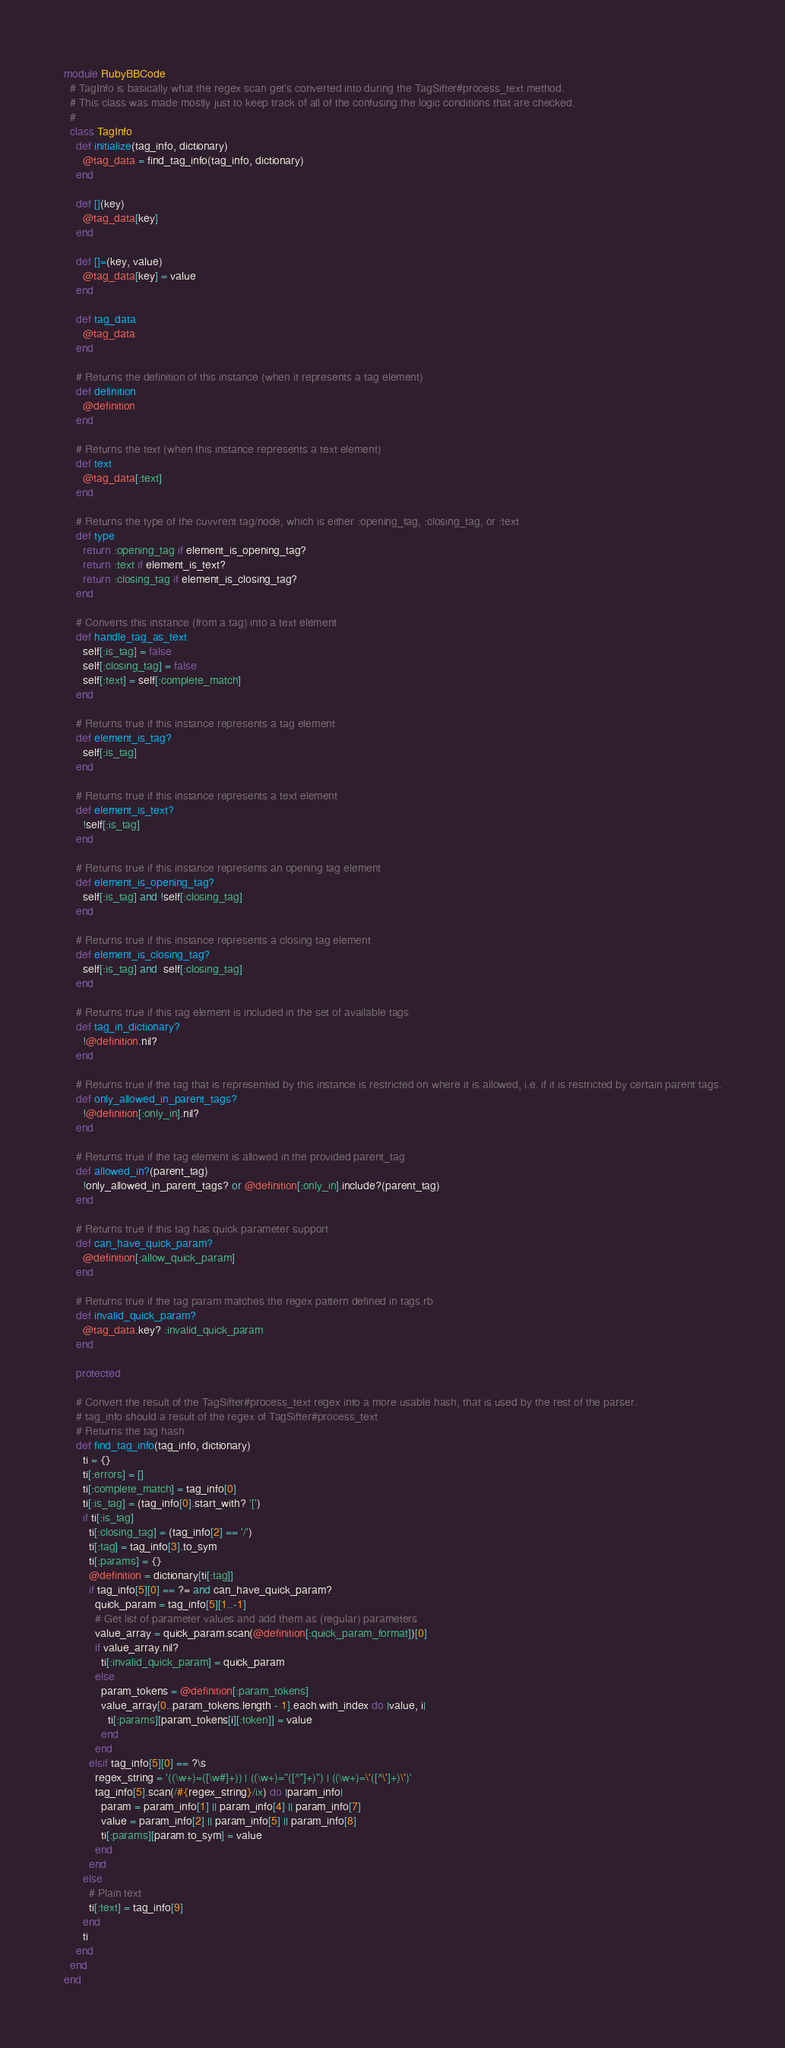<code> <loc_0><loc_0><loc_500><loc_500><_Ruby_>module RubyBBCode
  # TagInfo is basically what the regex scan get's converted into during the TagSifter#process_text method.
  # This class was made mostly just to keep track of all of the confusing the logic conditions that are checked.
  #
  class TagInfo
    def initialize(tag_info, dictionary)
      @tag_data = find_tag_info(tag_info, dictionary)
    end

    def [](key)
      @tag_data[key]
    end

    def []=(key, value)
      @tag_data[key] = value
    end

    def tag_data
      @tag_data
    end

    # Returns the definition of this instance (when it represents a tag element)
    def definition
      @definition
    end

    # Returns the text (when this instance represents a text element)
    def text
      @tag_data[:text]
    end

    # Returns the type of the cuvvrent tag/node, which is either :opening_tag, :closing_tag, or :text
    def type
      return :opening_tag if element_is_opening_tag?
      return :text if element_is_text?
      return :closing_tag if element_is_closing_tag?
    end

    # Converts this instance (from a tag) into a text element
    def handle_tag_as_text
      self[:is_tag] = false
      self[:closing_tag] = false
      self[:text] = self[:complete_match]
    end

    # Returns true if this instance represents a tag element
    def element_is_tag?
      self[:is_tag]
    end

    # Returns true if this instance represents a text element
    def element_is_text?
      !self[:is_tag]
    end

    # Returns true if this instance represents an opening tag element
    def element_is_opening_tag?
      self[:is_tag] and !self[:closing_tag]
    end

    # Returns true if this instance represents a closing tag element
    def element_is_closing_tag?
      self[:is_tag] and  self[:closing_tag]
    end

    # Returns true if this tag element is included in the set of available tags
    def tag_in_dictionary?
      !@definition.nil?
    end

    # Returns true if the tag that is represented by this instance is restricted on where it is allowed, i.e. if it is restricted by certain parent tags.
    def only_allowed_in_parent_tags?
      !@definition[:only_in].nil?
    end

    # Returns true if the tag element is allowed in the provided parent_tag
    def allowed_in?(parent_tag)
      !only_allowed_in_parent_tags? or @definition[:only_in].include?(parent_tag)
    end

    # Returns true if this tag has quick parameter support
    def can_have_quick_param?
      @definition[:allow_quick_param]
    end

    # Returns true if the tag param matches the regex pattern defined in tags.rb
    def invalid_quick_param?
      @tag_data.key? :invalid_quick_param
    end

    protected

    # Convert the result of the TagSifter#process_text regex into a more usable hash, that is used by the rest of the parser.
    # tag_info should a result of the regex of TagSifter#process_text
    # Returns the tag hash
    def find_tag_info(tag_info, dictionary)
      ti = {}
      ti[:errors] = []
      ti[:complete_match] = tag_info[0]
      ti[:is_tag] = (tag_info[0].start_with? '[')
      if ti[:is_tag]
        ti[:closing_tag] = (tag_info[2] == '/')
        ti[:tag] = tag_info[3].to_sym
        ti[:params] = {}
        @definition = dictionary[ti[:tag]]
        if tag_info[5][0] == ?= and can_have_quick_param?
          quick_param = tag_info[5][1..-1]
          # Get list of parameter values and add them as (regular) parameters
          value_array = quick_param.scan(@definition[:quick_param_format])[0]
          if value_array.nil?
            ti[:invalid_quick_param] = quick_param
          else
            param_tokens = @definition[:param_tokens]
            value_array[0..param_tokens.length - 1].each.with_index do |value, i|
              ti[:params][param_tokens[i][:token]] = value
            end
          end
        elsif tag_info[5][0] == ?\s
          regex_string = '((\w+)=([\w#]+)) | ((\w+)="([^"]+)") | ((\w+)=\'([^\']+)\')'
          tag_info[5].scan(/#{regex_string}/ix) do |param_info|
            param = param_info[1] || param_info[4] || param_info[7]
            value = param_info[2] || param_info[5] || param_info[8]
            ti[:params][param.to_sym] = value
          end
        end
      else
        # Plain text
        ti[:text] = tag_info[9]
      end
      ti
    end
  end
end
</code> 